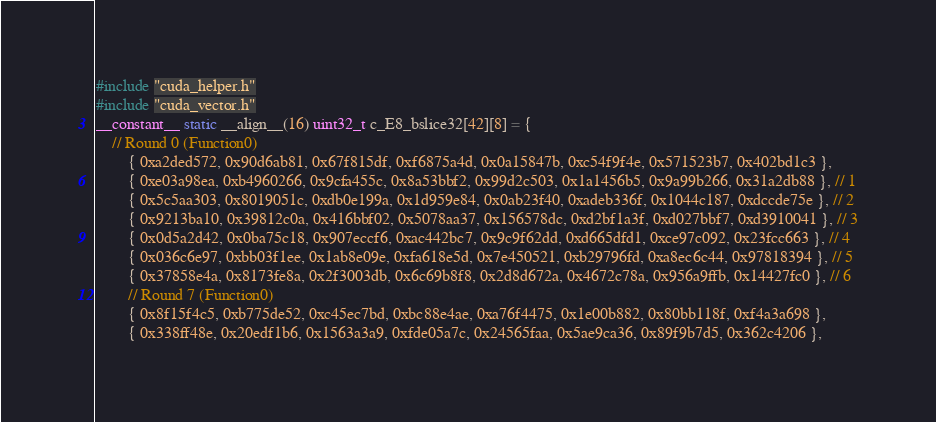<code> <loc_0><loc_0><loc_500><loc_500><_Cuda_>#include "cuda_helper.h"
#include "cuda_vector.h"
__constant__ static __align__(16) uint32_t c_E8_bslice32[42][8] = {
	// Round 0 (Function0)
		{ 0xa2ded572, 0x90d6ab81, 0x67f815df, 0xf6875a4d, 0x0a15847b, 0xc54f9f4e, 0x571523b7, 0x402bd1c3 },
		{ 0xe03a98ea, 0xb4960266, 0x9cfa455c, 0x8a53bbf2, 0x99d2c503, 0x1a1456b5, 0x9a99b266, 0x31a2db88 }, // 1
		{ 0x5c5aa303, 0x8019051c, 0xdb0e199a, 0x1d959e84, 0x0ab23f40, 0xadeb336f, 0x1044c187, 0xdccde75e }, // 2
		{ 0x9213ba10, 0x39812c0a, 0x416bbf02, 0x5078aa37, 0x156578dc, 0xd2bf1a3f, 0xd027bbf7, 0xd3910041 }, // 3
		{ 0x0d5a2d42, 0x0ba75c18, 0x907eccf6, 0xac442bc7, 0x9c9f62dd, 0xd665dfd1, 0xce97c092, 0x23fcc663 }, // 4
		{ 0x036c6e97, 0xbb03f1ee, 0x1ab8e09e, 0xfa618e5d, 0x7e450521, 0xb29796fd, 0xa8ec6c44, 0x97818394 }, // 5
		{ 0x37858e4a, 0x8173fe8a, 0x2f3003db, 0x6c69b8f8, 0x2d8d672a, 0x4672c78a, 0x956a9ffb, 0x14427fc0 }, // 6
		// Round 7 (Function0)
		{ 0x8f15f4c5, 0xb775de52, 0xc45ec7bd, 0xbc88e4ae, 0xa76f4475, 0x1e00b882, 0x80bb118f, 0xf4a3a698 },
		{ 0x338ff48e, 0x20edf1b6, 0x1563a3a9, 0xfde05a7c, 0x24565faa, 0x5ae9ca36, 0x89f9b7d5, 0x362c4206 },</code> 